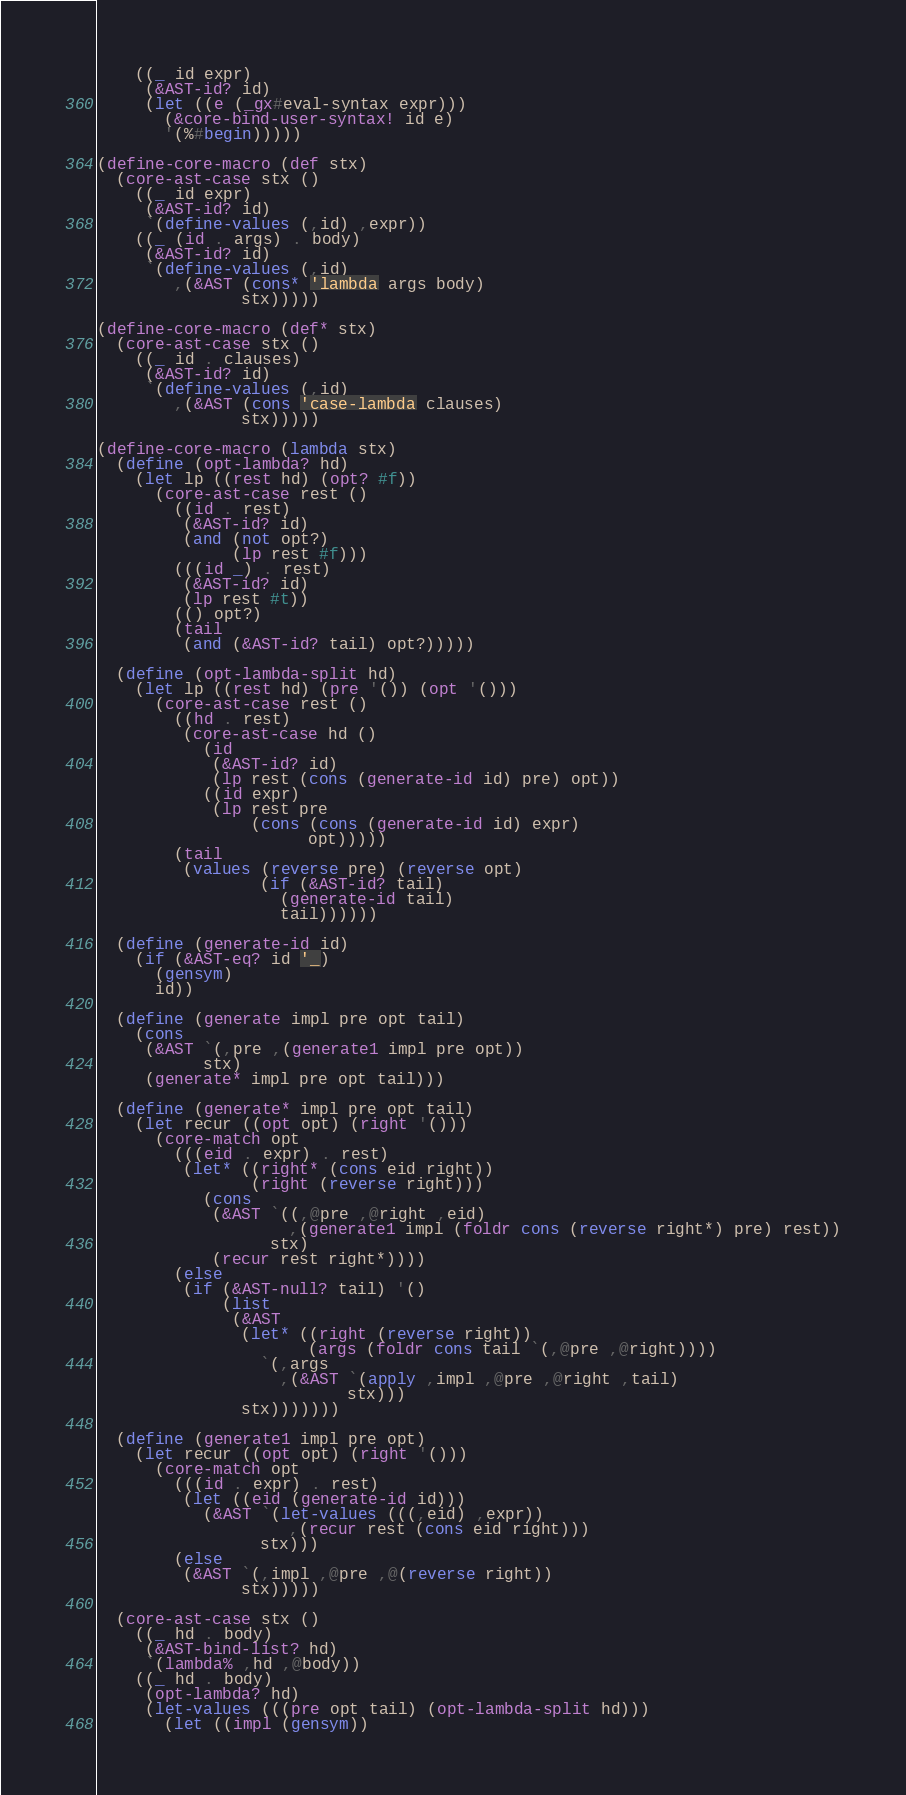Convert code to text. <code><loc_0><loc_0><loc_500><loc_500><_Scheme_>    ((_ id expr)
     (&AST-id? id)
     (let ((e (_gx#eval-syntax expr)))
       (&core-bind-user-syntax! id e)
       '(%#begin)))))

(define-core-macro (def stx)
  (core-ast-case stx ()
    ((_ id expr)
     (&AST-id? id)
     `(define-values (,id) ,expr))
    ((_ (id . args) . body)
     (&AST-id? id)
     `(define-values (,id)
        ,(&AST (cons* 'lambda args body)
               stx)))))

(define-core-macro (def* stx)
  (core-ast-case stx ()
    ((_ id . clauses)
     (&AST-id? id)
     `(define-values (,id)
        ,(&AST (cons 'case-lambda clauses)
               stx)))))

(define-core-macro (lambda stx)
  (define (opt-lambda? hd)
    (let lp ((rest hd) (opt? #f))
      (core-ast-case rest ()
        ((id . rest)
         (&AST-id? id)
         (and (not opt?)
              (lp rest #f)))
        (((id _) . rest)
         (&AST-id? id)
         (lp rest #t))
        (() opt?)
        (tail
         (and (&AST-id? tail) opt?)))))

  (define (opt-lambda-split hd)
    (let lp ((rest hd) (pre '()) (opt '()))
      (core-ast-case rest ()
        ((hd . rest)
         (core-ast-case hd ()
           (id
            (&AST-id? id)
            (lp rest (cons (generate-id id) pre) opt))
           ((id expr)
            (lp rest pre
                (cons (cons (generate-id id) expr)
                      opt)))))
        (tail
         (values (reverse pre) (reverse opt)
                 (if (&AST-id? tail)
                   (generate-id tail)
                   tail))))))

  (define (generate-id id)
    (if (&AST-eq? id '_)
      (gensym)
      id))

  (define (generate impl pre opt tail)
    (cons
     (&AST `(,pre ,(generate1 impl pre opt))
           stx)
     (generate* impl pre opt tail)))

  (define (generate* impl pre opt tail)
    (let recur ((opt opt) (right '()))
      (core-match opt
        (((eid . expr) . rest)
         (let* ((right* (cons eid right))
                (right (reverse right)))
           (cons
            (&AST `((,@pre ,@right ,eid)
                    ,(generate1 impl (foldr cons (reverse right*) pre) rest))
                  stx)
            (recur rest right*))))
        (else
         (if (&AST-null? tail) '()
             (list
              (&AST
               (let* ((right (reverse right))
                      (args (foldr cons tail `(,@pre ,@right))))
                 `(,args
                   ,(&AST `(apply ,impl ,@pre ,@right ,tail)
                          stx)))
               stx)))))))

  (define (generate1 impl pre opt)
    (let recur ((opt opt) (right '()))
      (core-match opt
        (((id . expr) . rest)
         (let ((eid (generate-id id)))
           (&AST `(let-values (((,eid) ,expr))
                    ,(recur rest (cons eid right)))
                 stx)))
        (else
         (&AST `(,impl ,@pre ,@(reverse right))
               stx)))))

  (core-ast-case stx ()
    ((_ hd . body)
     (&AST-bind-list? hd)
     `(lambda% ,hd ,@body))
    ((_ hd . body)
     (opt-lambda? hd)
     (let-values (((pre opt tail) (opt-lambda-split hd)))
       (let ((impl (gensym))</code> 